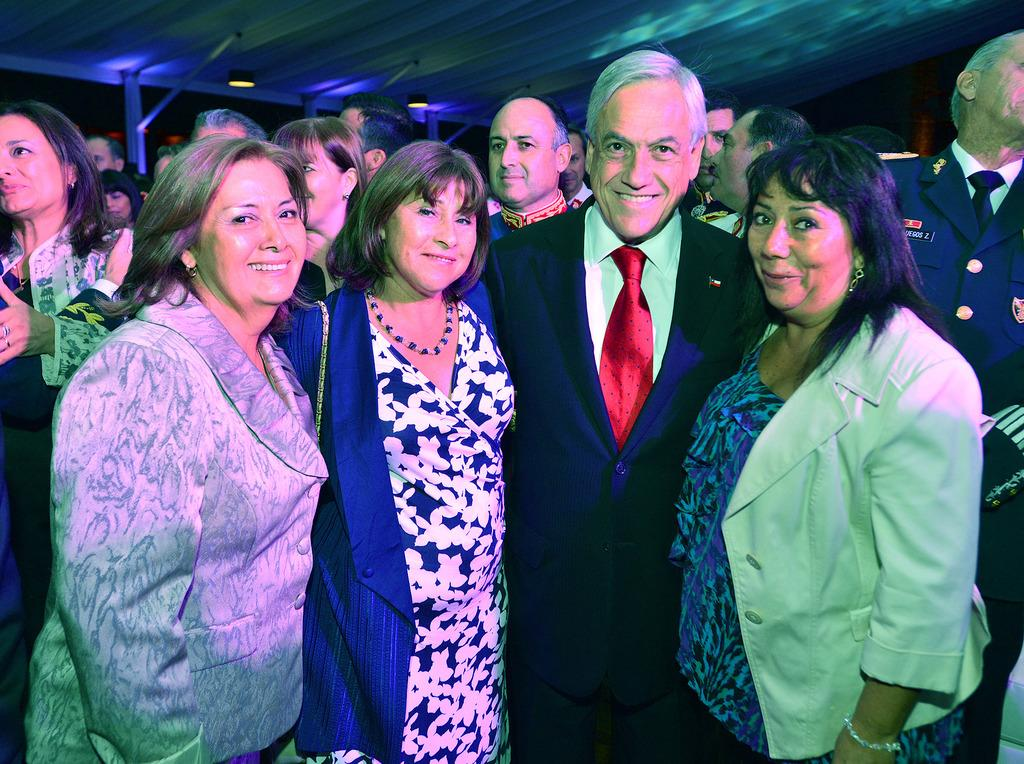How many people are in the image? There are four people in the image. What is the facial expression of the people in the image? The four people are smiling. Are there any other people visible in the image? Yes, there are other people standing behind them. What type of lighting is present in the image? There are lights visible in the image. What material can be seen in the image? There are metal rods in the image. What type of nut is being cracked by the people in the image? There is no nut present in the image; the people are simply smiling. 